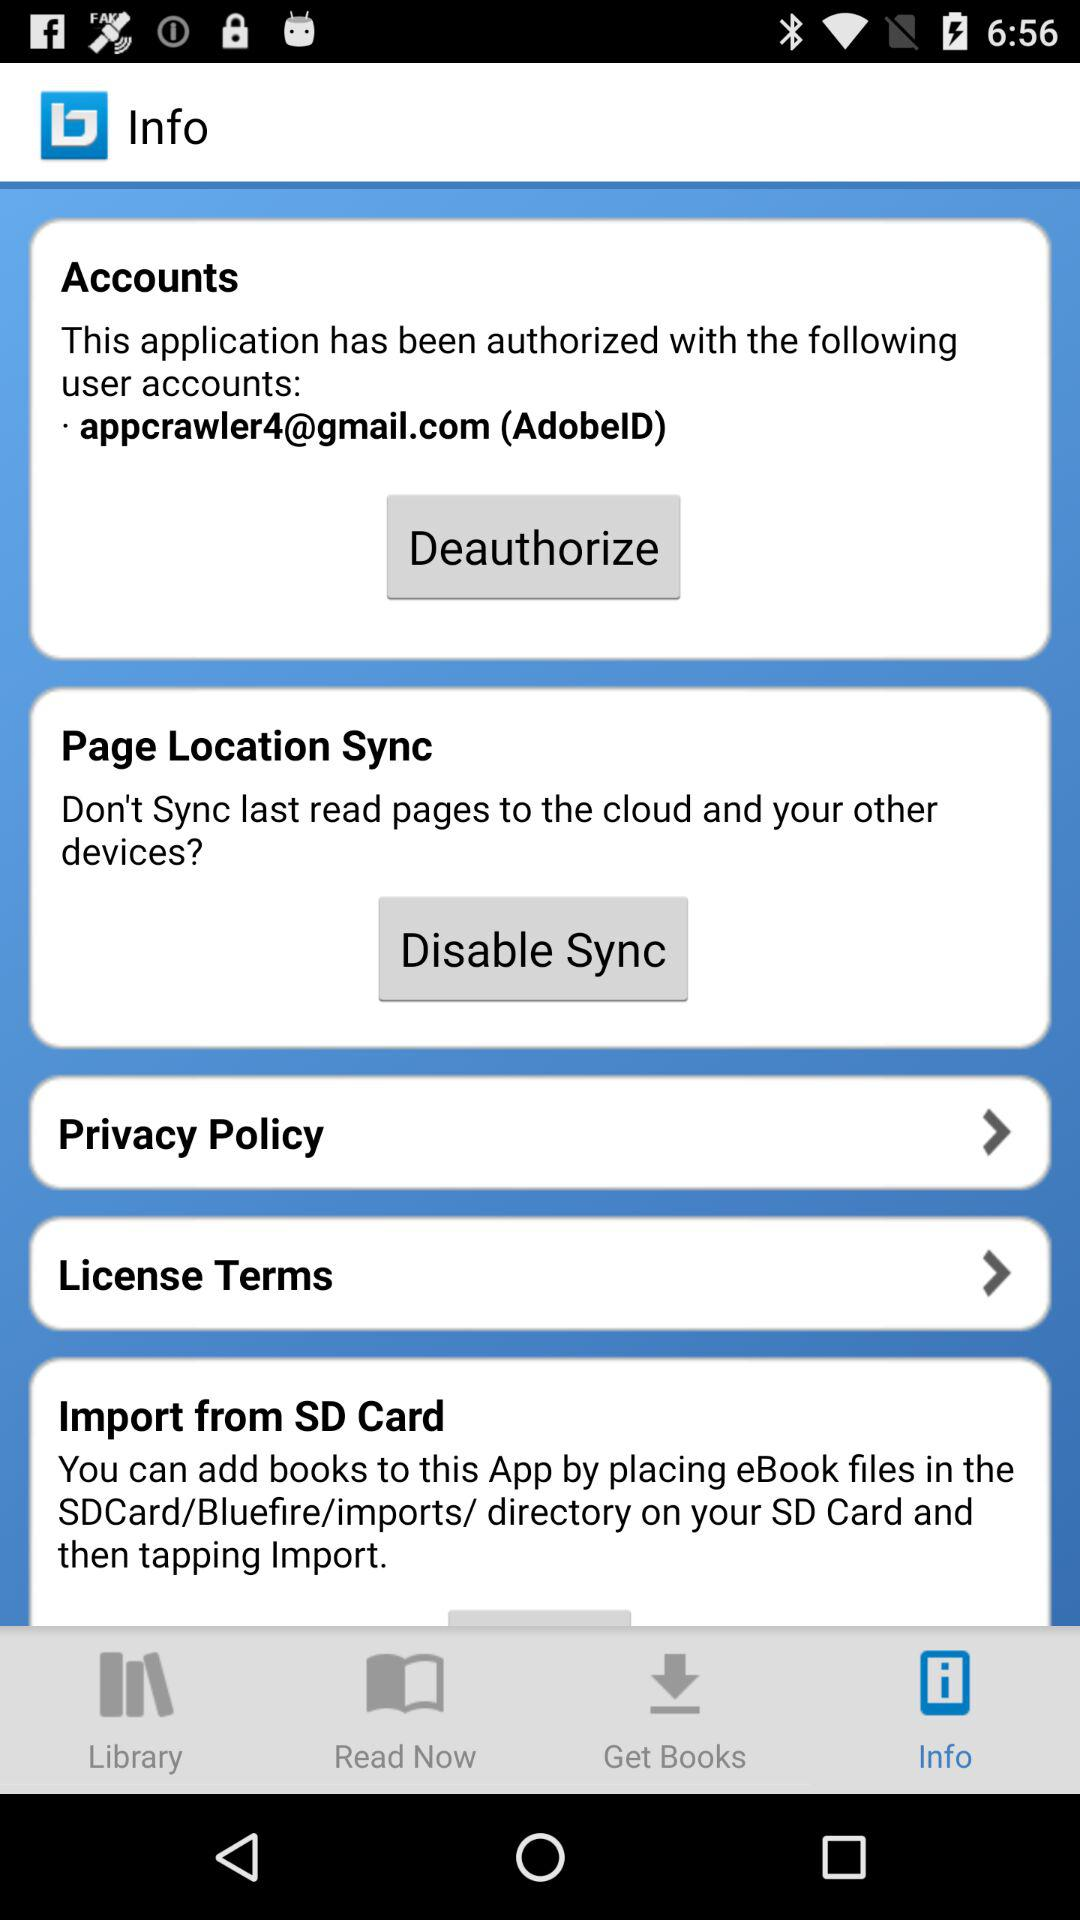Which tab is selected? The selected tab is "Info". 